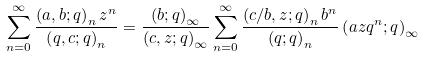<formula> <loc_0><loc_0><loc_500><loc_500>\sum _ { n = 0 } ^ { \infty } \frac { \left ( a , b ; q \right ) _ { n } z ^ { n } } { \left ( q , c ; q \right ) _ { n } } = \frac { \left ( b ; q \right ) _ { \infty } } { \left ( c , z ; q \right ) _ { \infty } } \sum _ { n = 0 } ^ { \infty } \frac { \left ( c / b , z ; q \right ) _ { n } b ^ { n } } { \left ( q ; q \right ) _ { n } } \left ( a z q ^ { n } ; q \right ) _ { \infty }</formula> 